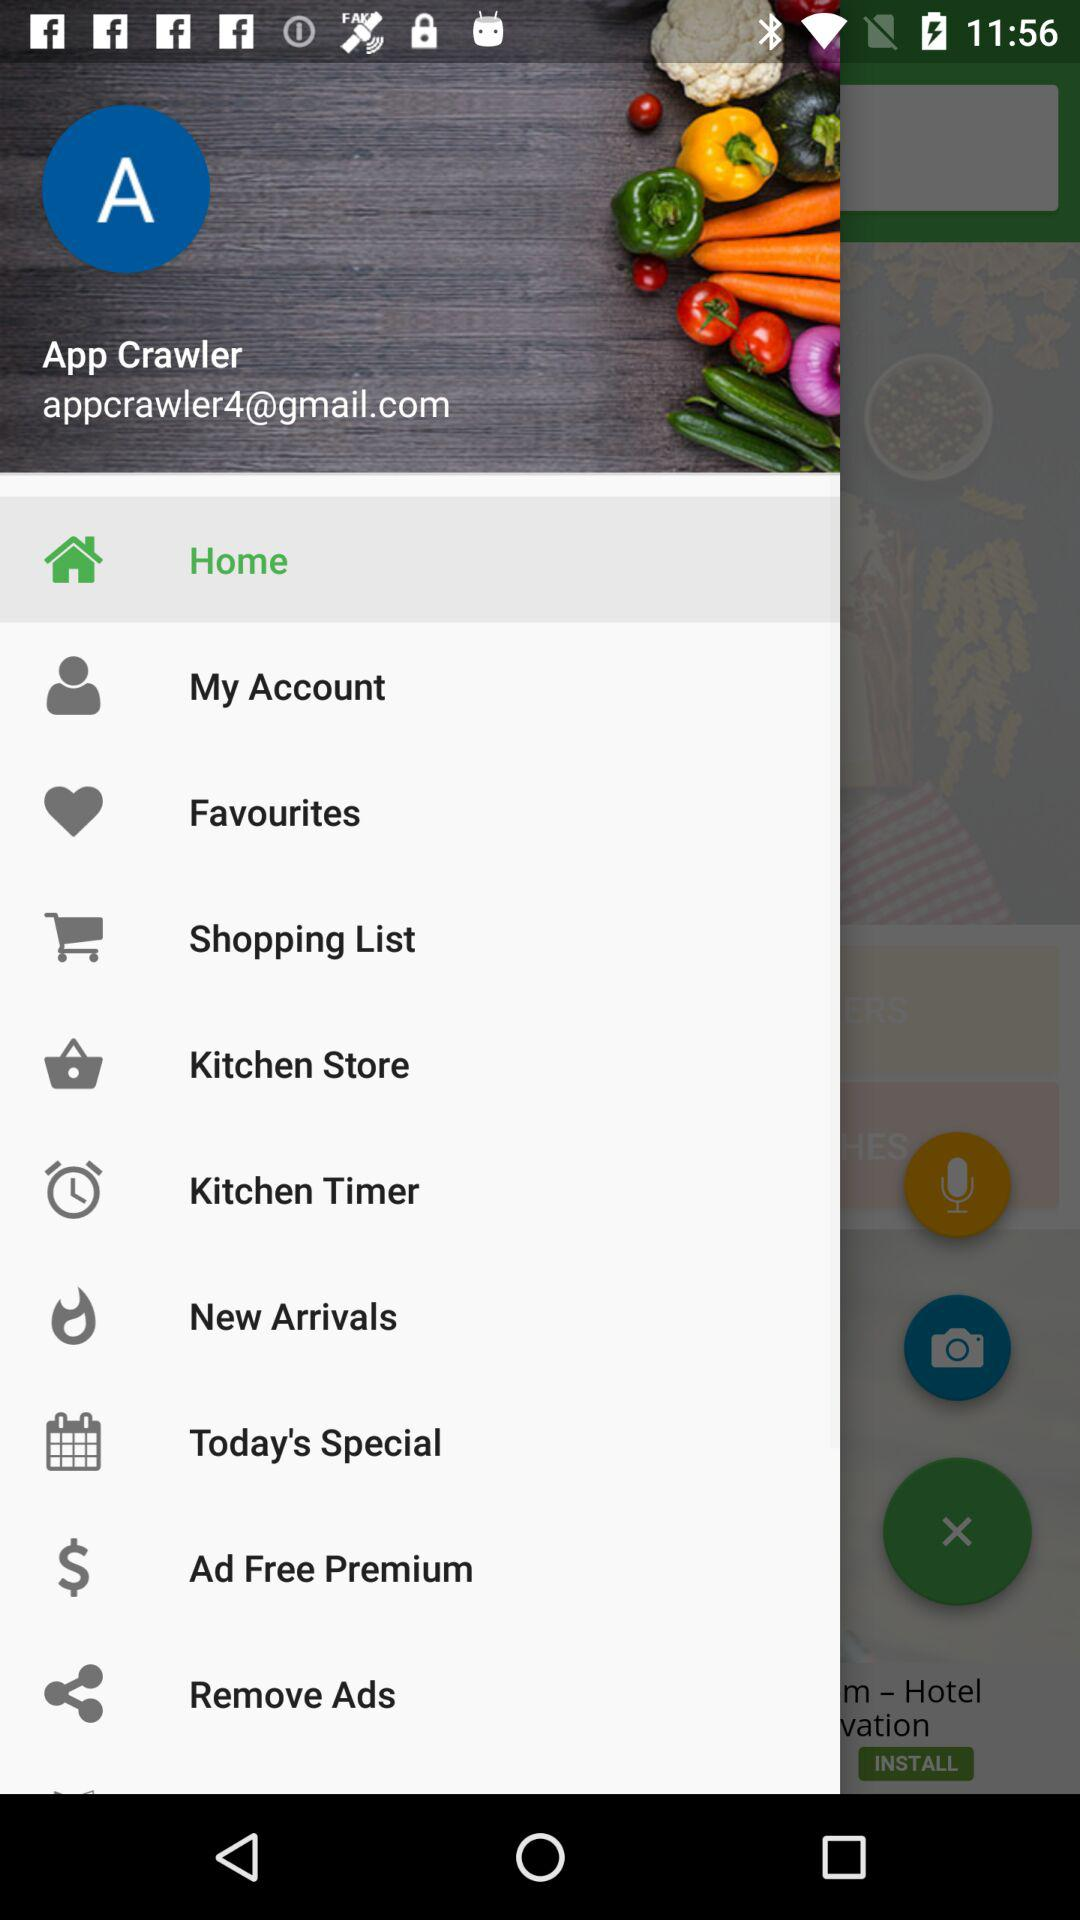Which item is selected in the menu? The selected item in the menu is "Home". 